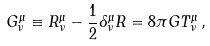Convert formula to latex. <formula><loc_0><loc_0><loc_500><loc_500>G ^ { \mu } _ { \nu } \equiv R ^ { \mu } _ { \nu } - \frac { 1 } { 2 } \delta ^ { \mu } _ { \nu } R = 8 \pi G T ^ { \mu } _ { \nu } \, ,</formula> 